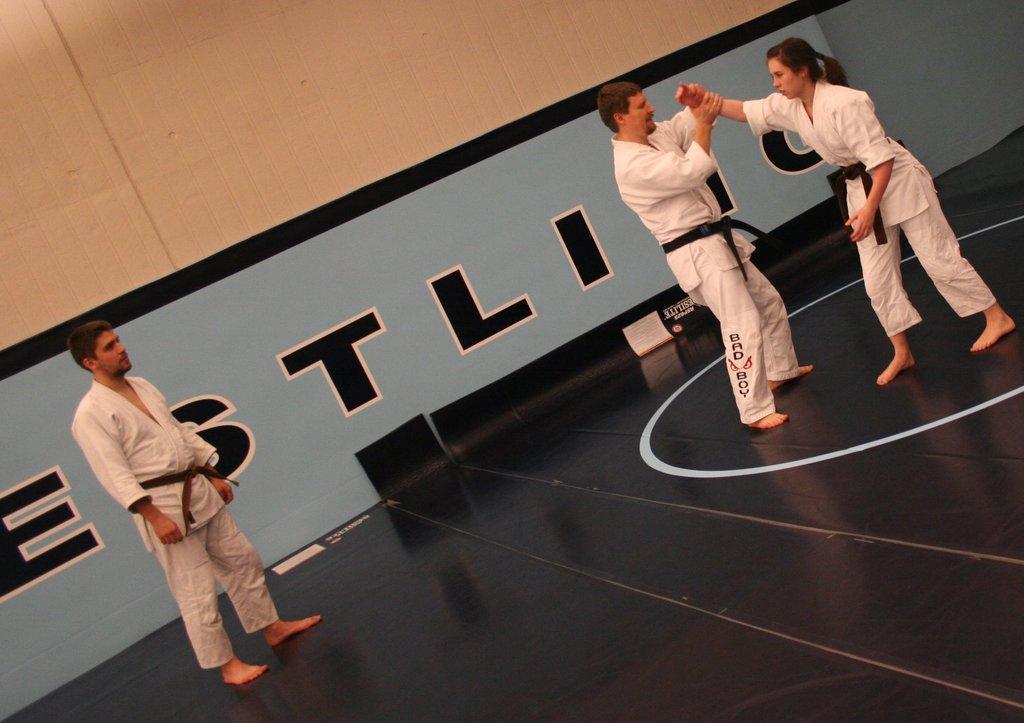How would you summarize this image in a sentence or two? In this image there are three people standing. To the left there is a man standing. To the right there is a woman and a man standing. The man is holding the hand of the woman. Behind them there is a wall. There is text on the wall. 